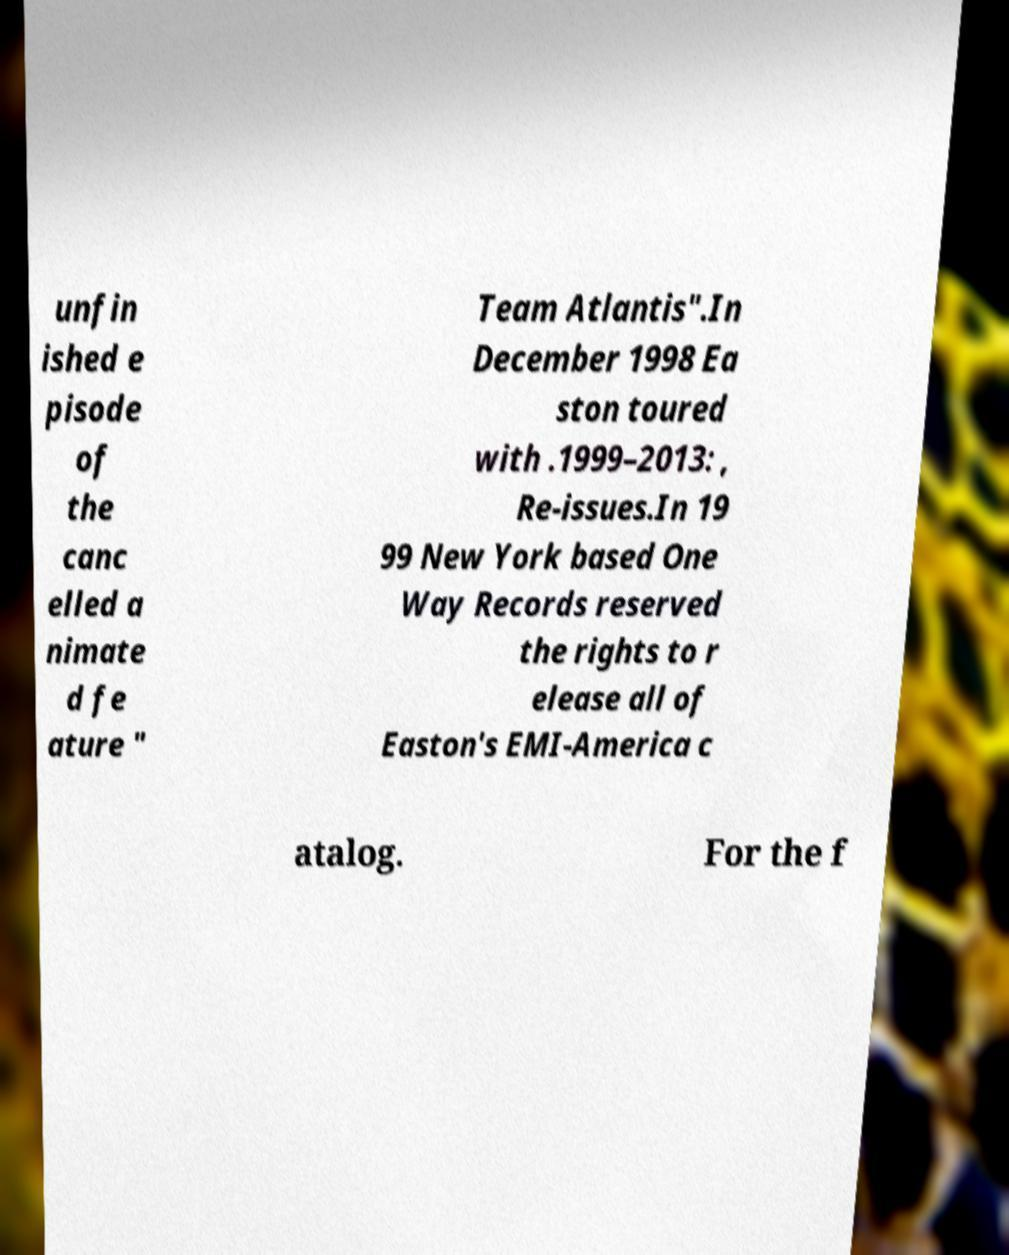What messages or text are displayed in this image? I need them in a readable, typed format. unfin ished e pisode of the canc elled a nimate d fe ature " Team Atlantis".In December 1998 Ea ston toured with .1999–2013: , Re-issues.In 19 99 New York based One Way Records reserved the rights to r elease all of Easton's EMI-America c atalog. For the f 